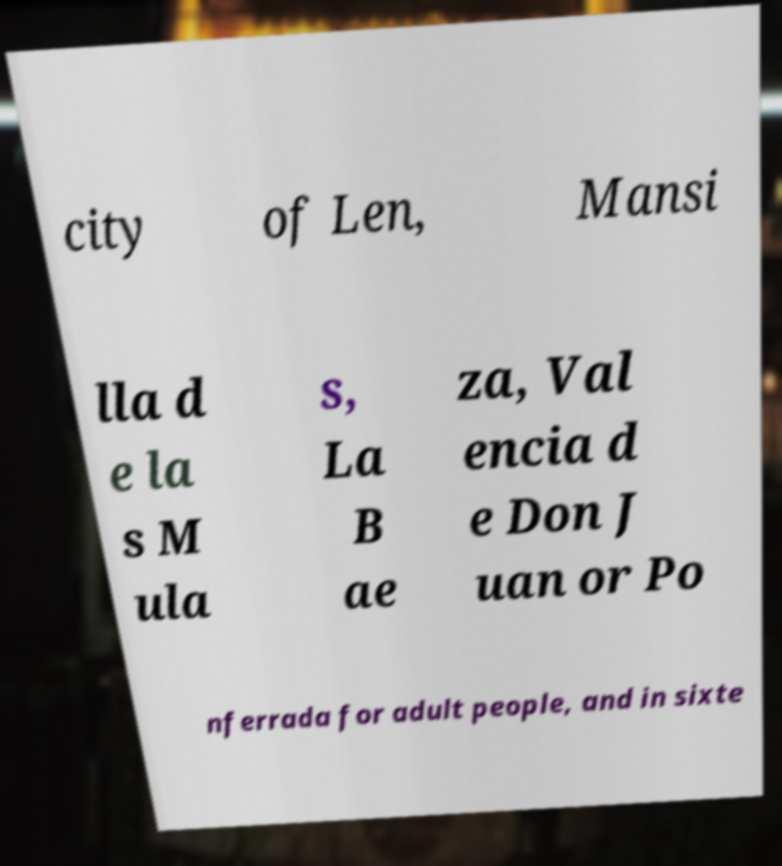For documentation purposes, I need the text within this image transcribed. Could you provide that? city of Len, Mansi lla d e la s M ula s, La B ae za, Val encia d e Don J uan or Po nferrada for adult people, and in sixte 